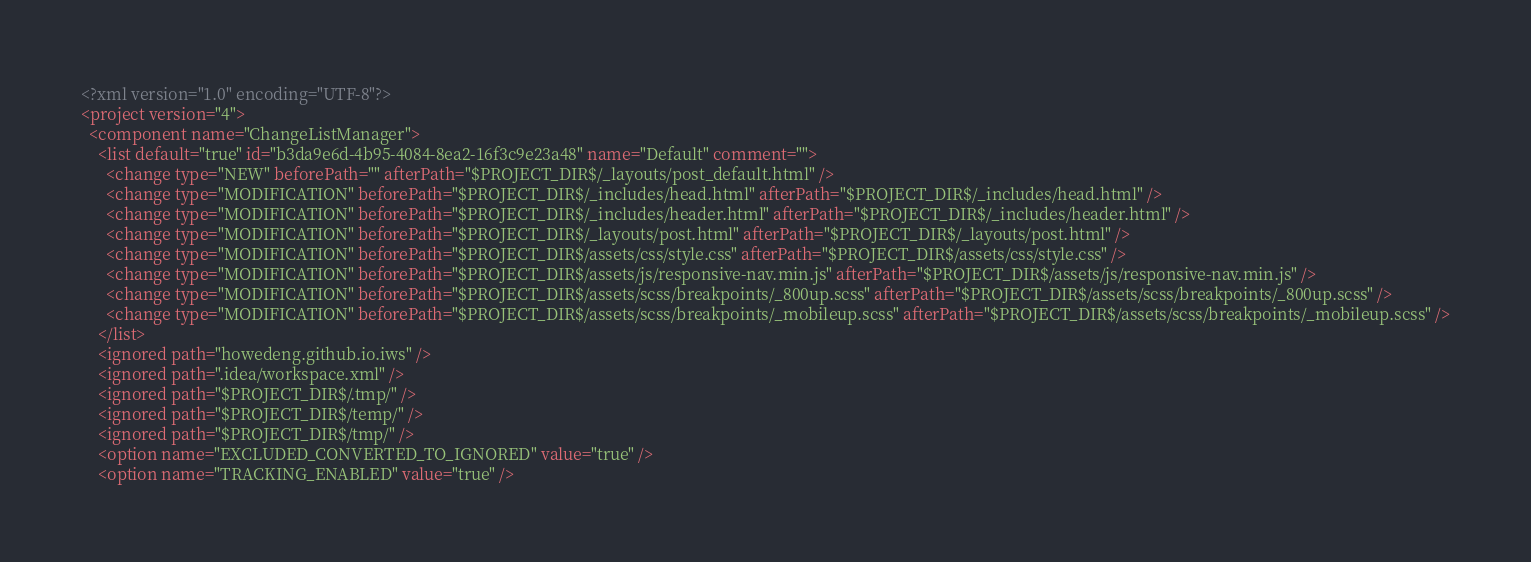<code> <loc_0><loc_0><loc_500><loc_500><_XML_><?xml version="1.0" encoding="UTF-8"?>
<project version="4">
  <component name="ChangeListManager">
    <list default="true" id="b3da9e6d-4b95-4084-8ea2-16f3c9e23a48" name="Default" comment="">
      <change type="NEW" beforePath="" afterPath="$PROJECT_DIR$/_layouts/post_default.html" />
      <change type="MODIFICATION" beforePath="$PROJECT_DIR$/_includes/head.html" afterPath="$PROJECT_DIR$/_includes/head.html" />
      <change type="MODIFICATION" beforePath="$PROJECT_DIR$/_includes/header.html" afterPath="$PROJECT_DIR$/_includes/header.html" />
      <change type="MODIFICATION" beforePath="$PROJECT_DIR$/_layouts/post.html" afterPath="$PROJECT_DIR$/_layouts/post.html" />
      <change type="MODIFICATION" beforePath="$PROJECT_DIR$/assets/css/style.css" afterPath="$PROJECT_DIR$/assets/css/style.css" />
      <change type="MODIFICATION" beforePath="$PROJECT_DIR$/assets/js/responsive-nav.min.js" afterPath="$PROJECT_DIR$/assets/js/responsive-nav.min.js" />
      <change type="MODIFICATION" beforePath="$PROJECT_DIR$/assets/scss/breakpoints/_800up.scss" afterPath="$PROJECT_DIR$/assets/scss/breakpoints/_800up.scss" />
      <change type="MODIFICATION" beforePath="$PROJECT_DIR$/assets/scss/breakpoints/_mobileup.scss" afterPath="$PROJECT_DIR$/assets/scss/breakpoints/_mobileup.scss" />
    </list>
    <ignored path="howedeng.github.io.iws" />
    <ignored path=".idea/workspace.xml" />
    <ignored path="$PROJECT_DIR$/.tmp/" />
    <ignored path="$PROJECT_DIR$/temp/" />
    <ignored path="$PROJECT_DIR$/tmp/" />
    <option name="EXCLUDED_CONVERTED_TO_IGNORED" value="true" />
    <option name="TRACKING_ENABLED" value="true" /></code> 